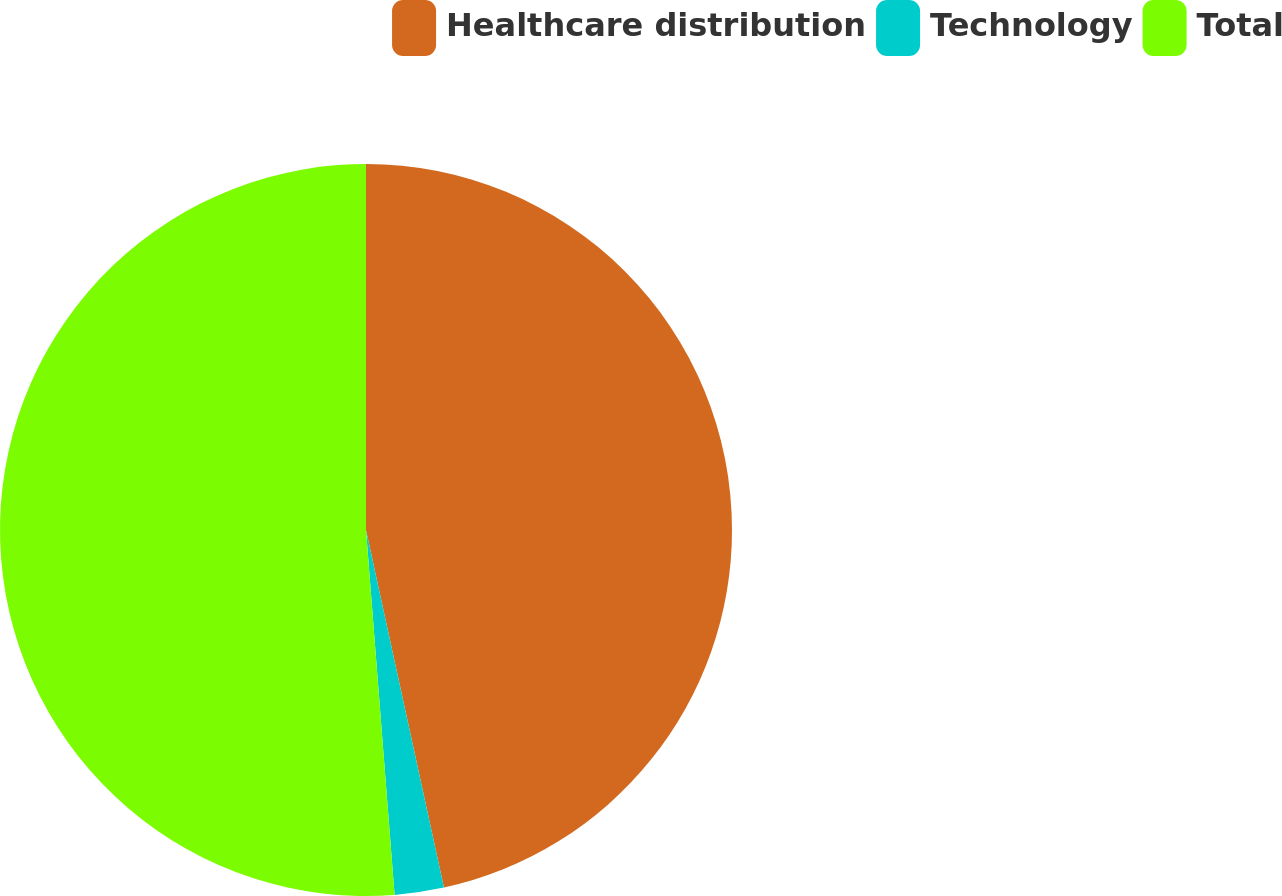Convert chart. <chart><loc_0><loc_0><loc_500><loc_500><pie_chart><fcel>Healthcare distribution<fcel>Technology<fcel>Total<nl><fcel>46.59%<fcel>2.17%<fcel>51.25%<nl></chart> 